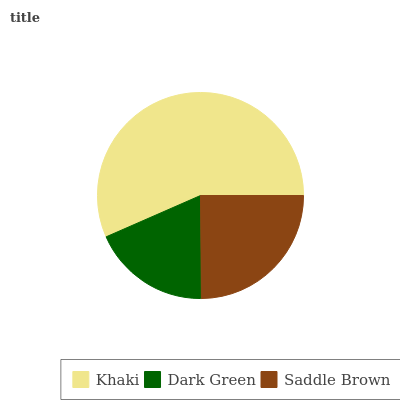Is Dark Green the minimum?
Answer yes or no. Yes. Is Khaki the maximum?
Answer yes or no. Yes. Is Saddle Brown the minimum?
Answer yes or no. No. Is Saddle Brown the maximum?
Answer yes or no. No. Is Saddle Brown greater than Dark Green?
Answer yes or no. Yes. Is Dark Green less than Saddle Brown?
Answer yes or no. Yes. Is Dark Green greater than Saddle Brown?
Answer yes or no. No. Is Saddle Brown less than Dark Green?
Answer yes or no. No. Is Saddle Brown the high median?
Answer yes or no. Yes. Is Saddle Brown the low median?
Answer yes or no. Yes. Is Khaki the high median?
Answer yes or no. No. Is Dark Green the low median?
Answer yes or no. No. 